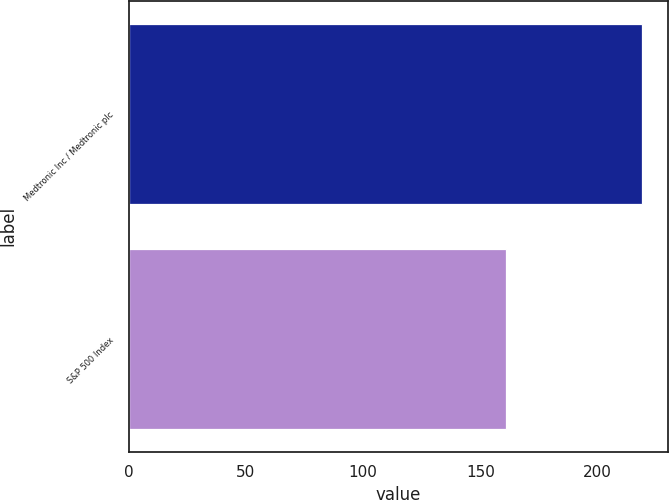Convert chart to OTSL. <chart><loc_0><loc_0><loc_500><loc_500><bar_chart><fcel>Medtronic Inc / Medtronic plc<fcel>S&P 500 Index<nl><fcel>219.09<fcel>160.85<nl></chart> 